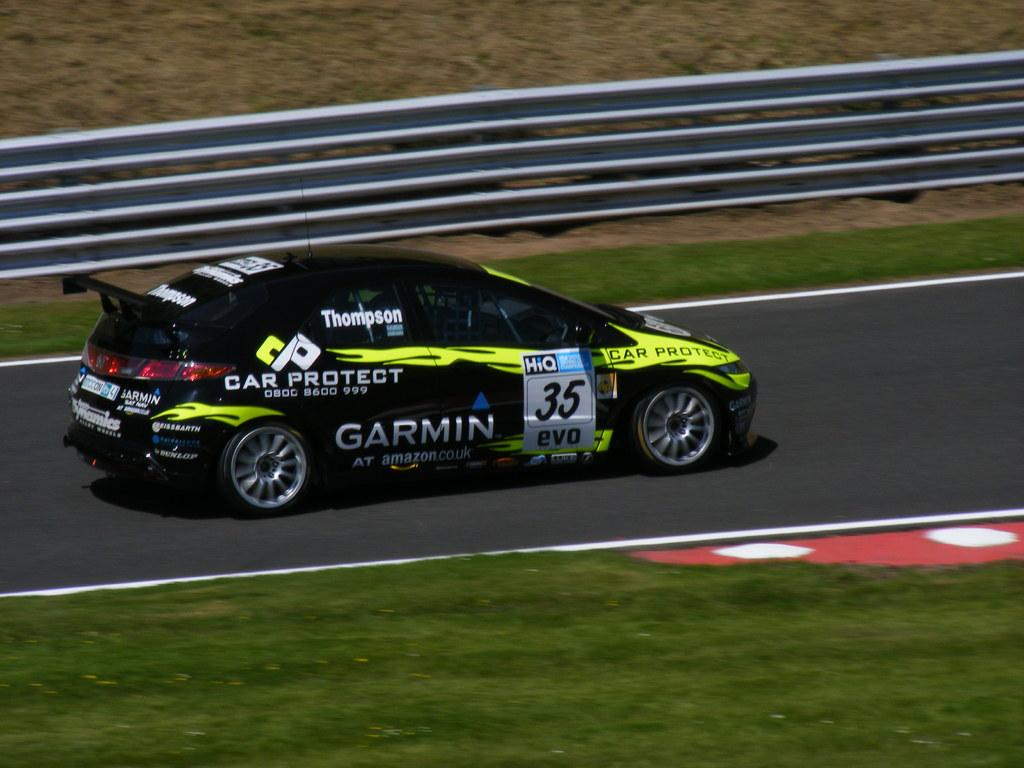What color is the car in the image? The car in the image is black. What can be seen in the background of the image? There is a road and grass visible in the image. How many sticks are being used to copy the car in the image? There are no sticks or copying activity present in the image. 